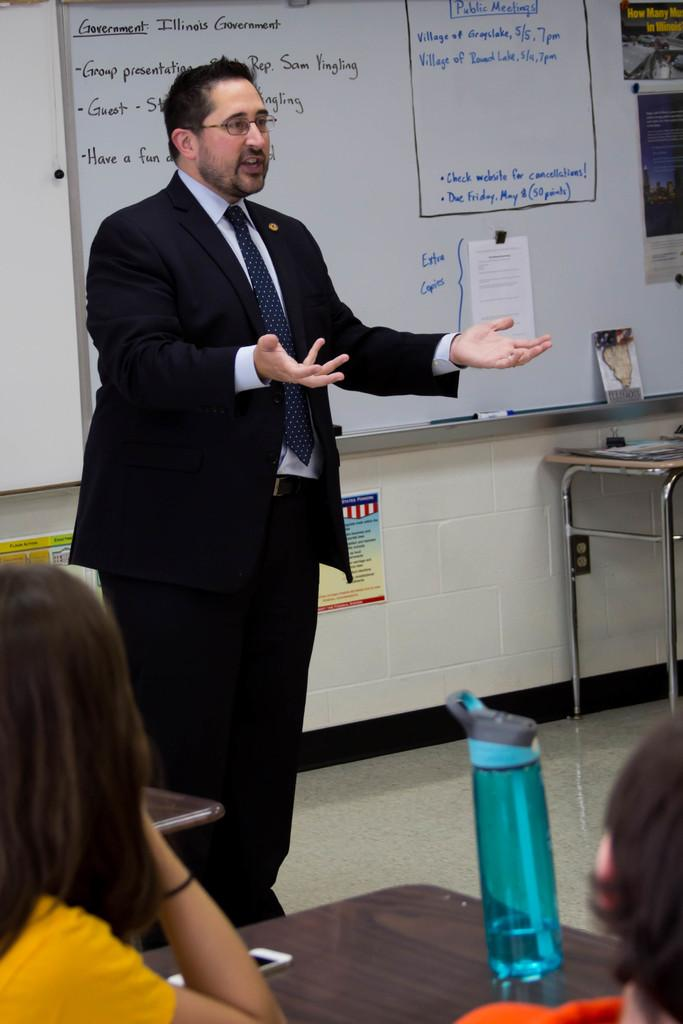Provide a one-sentence caption for the provided image. A man standing in front of a whiteboard with topics about Government. 